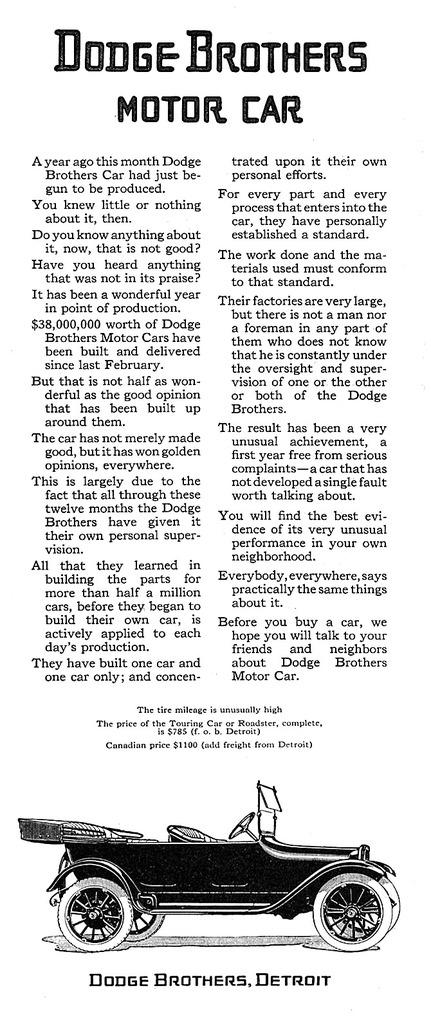What is present on the paper in the image? There is a paper in the image, and it has a vehicle depicted on it. Are there any words or letters on the paper? Yes, there is writing on the paper. How much salt is sprinkled on the vehicle in the image? There is no salt present in the image; it only shows a paper with a vehicle and writing on it. 